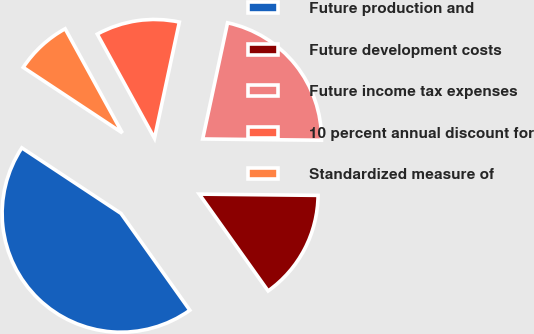<chart> <loc_0><loc_0><loc_500><loc_500><pie_chart><fcel>Future production and<fcel>Future development costs<fcel>Future income tax expenses<fcel>10 percent annual discount for<fcel>Standardized measure of<nl><fcel>44.14%<fcel>14.99%<fcel>21.81%<fcel>11.35%<fcel>7.71%<nl></chart> 